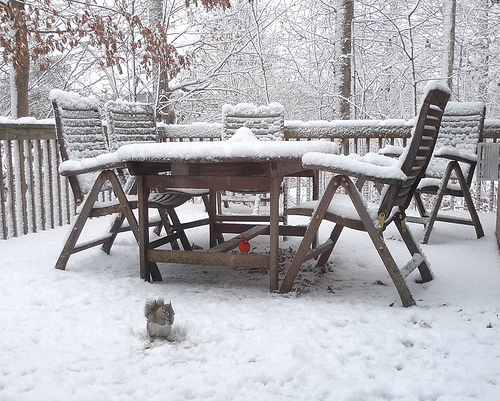<image>
Is the snow behind the chair? Yes. From this viewpoint, the snow is positioned behind the chair, with the chair partially or fully occluding the snow. 